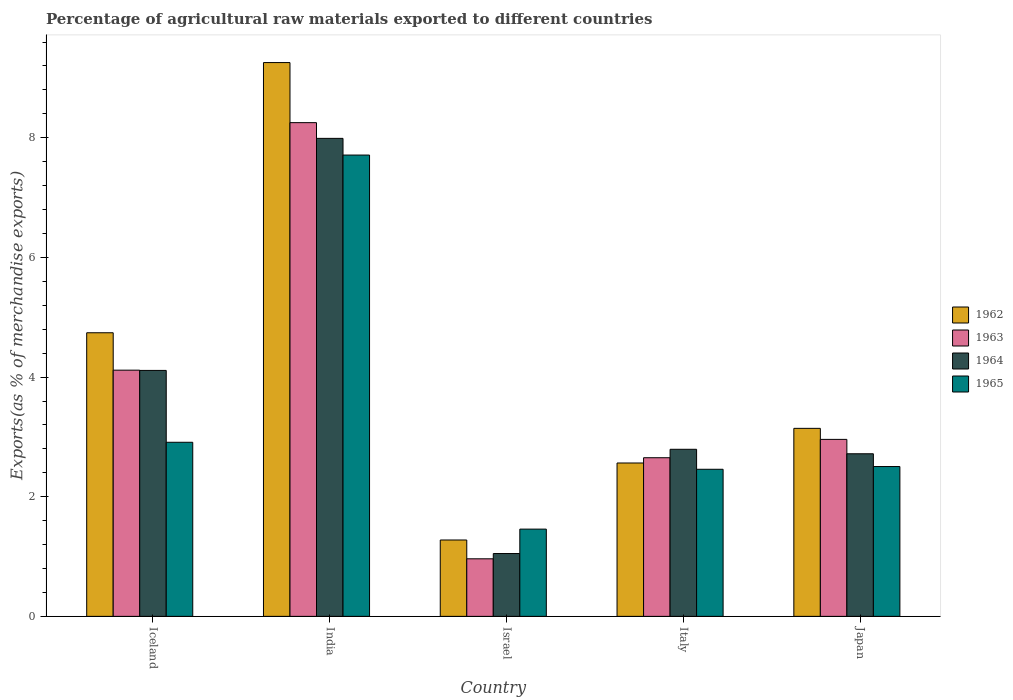How many groups of bars are there?
Offer a very short reply. 5. How many bars are there on the 1st tick from the right?
Keep it short and to the point. 4. What is the percentage of exports to different countries in 1962 in Japan?
Make the answer very short. 3.14. Across all countries, what is the maximum percentage of exports to different countries in 1963?
Offer a terse response. 8.25. Across all countries, what is the minimum percentage of exports to different countries in 1962?
Your answer should be very brief. 1.28. In which country was the percentage of exports to different countries in 1965 minimum?
Offer a terse response. Israel. What is the total percentage of exports to different countries in 1963 in the graph?
Provide a succinct answer. 18.94. What is the difference between the percentage of exports to different countries in 1964 in Israel and that in Japan?
Provide a succinct answer. -1.67. What is the difference between the percentage of exports to different countries in 1965 in India and the percentage of exports to different countries in 1964 in Israel?
Keep it short and to the point. 6.66. What is the average percentage of exports to different countries in 1964 per country?
Provide a succinct answer. 3.73. What is the difference between the percentage of exports to different countries of/in 1962 and percentage of exports to different countries of/in 1964 in Israel?
Keep it short and to the point. 0.23. In how many countries, is the percentage of exports to different countries in 1965 greater than 9.2 %?
Provide a short and direct response. 0. What is the ratio of the percentage of exports to different countries in 1965 in Israel to that in Italy?
Your answer should be very brief. 0.59. Is the percentage of exports to different countries in 1965 in Israel less than that in Italy?
Your answer should be very brief. Yes. What is the difference between the highest and the second highest percentage of exports to different countries in 1962?
Offer a terse response. 6.11. What is the difference between the highest and the lowest percentage of exports to different countries in 1965?
Keep it short and to the point. 6.25. Is the sum of the percentage of exports to different countries in 1965 in Italy and Japan greater than the maximum percentage of exports to different countries in 1962 across all countries?
Your answer should be compact. No. What does the 4th bar from the left in Iceland represents?
Your answer should be compact. 1965. What does the 1st bar from the right in India represents?
Keep it short and to the point. 1965. Are the values on the major ticks of Y-axis written in scientific E-notation?
Provide a short and direct response. No. Does the graph contain any zero values?
Make the answer very short. No. Does the graph contain grids?
Offer a terse response. No. How are the legend labels stacked?
Your answer should be compact. Vertical. What is the title of the graph?
Make the answer very short. Percentage of agricultural raw materials exported to different countries. Does "1989" appear as one of the legend labels in the graph?
Your answer should be very brief. No. What is the label or title of the Y-axis?
Offer a very short reply. Exports(as % of merchandise exports). What is the Exports(as % of merchandise exports) of 1962 in Iceland?
Your answer should be compact. 4.74. What is the Exports(as % of merchandise exports) of 1963 in Iceland?
Your answer should be compact. 4.12. What is the Exports(as % of merchandise exports) of 1964 in Iceland?
Your answer should be very brief. 4.11. What is the Exports(as % of merchandise exports) in 1965 in Iceland?
Your response must be concise. 2.91. What is the Exports(as % of merchandise exports) in 1962 in India?
Make the answer very short. 9.26. What is the Exports(as % of merchandise exports) in 1963 in India?
Give a very brief answer. 8.25. What is the Exports(as % of merchandise exports) in 1964 in India?
Give a very brief answer. 7.99. What is the Exports(as % of merchandise exports) in 1965 in India?
Offer a very short reply. 7.71. What is the Exports(as % of merchandise exports) of 1962 in Israel?
Make the answer very short. 1.28. What is the Exports(as % of merchandise exports) of 1963 in Israel?
Your answer should be compact. 0.96. What is the Exports(as % of merchandise exports) of 1964 in Israel?
Ensure brevity in your answer.  1.05. What is the Exports(as % of merchandise exports) of 1965 in Israel?
Make the answer very short. 1.46. What is the Exports(as % of merchandise exports) of 1962 in Italy?
Your answer should be very brief. 2.56. What is the Exports(as % of merchandise exports) of 1963 in Italy?
Your answer should be compact. 2.65. What is the Exports(as % of merchandise exports) in 1964 in Italy?
Give a very brief answer. 2.79. What is the Exports(as % of merchandise exports) in 1965 in Italy?
Offer a very short reply. 2.46. What is the Exports(as % of merchandise exports) of 1962 in Japan?
Your response must be concise. 3.14. What is the Exports(as % of merchandise exports) of 1963 in Japan?
Offer a terse response. 2.96. What is the Exports(as % of merchandise exports) in 1964 in Japan?
Make the answer very short. 2.72. What is the Exports(as % of merchandise exports) of 1965 in Japan?
Provide a succinct answer. 2.5. Across all countries, what is the maximum Exports(as % of merchandise exports) of 1962?
Keep it short and to the point. 9.26. Across all countries, what is the maximum Exports(as % of merchandise exports) of 1963?
Offer a terse response. 8.25. Across all countries, what is the maximum Exports(as % of merchandise exports) of 1964?
Provide a succinct answer. 7.99. Across all countries, what is the maximum Exports(as % of merchandise exports) of 1965?
Make the answer very short. 7.71. Across all countries, what is the minimum Exports(as % of merchandise exports) in 1962?
Keep it short and to the point. 1.28. Across all countries, what is the minimum Exports(as % of merchandise exports) in 1963?
Offer a terse response. 0.96. Across all countries, what is the minimum Exports(as % of merchandise exports) in 1964?
Keep it short and to the point. 1.05. Across all countries, what is the minimum Exports(as % of merchandise exports) of 1965?
Offer a terse response. 1.46. What is the total Exports(as % of merchandise exports) in 1962 in the graph?
Provide a succinct answer. 20.98. What is the total Exports(as % of merchandise exports) of 1963 in the graph?
Make the answer very short. 18.94. What is the total Exports(as % of merchandise exports) in 1964 in the graph?
Your answer should be compact. 18.66. What is the total Exports(as % of merchandise exports) in 1965 in the graph?
Offer a very short reply. 17.04. What is the difference between the Exports(as % of merchandise exports) in 1962 in Iceland and that in India?
Your response must be concise. -4.52. What is the difference between the Exports(as % of merchandise exports) in 1963 in Iceland and that in India?
Your answer should be very brief. -4.14. What is the difference between the Exports(as % of merchandise exports) of 1964 in Iceland and that in India?
Your answer should be very brief. -3.88. What is the difference between the Exports(as % of merchandise exports) of 1965 in Iceland and that in India?
Keep it short and to the point. -4.8. What is the difference between the Exports(as % of merchandise exports) in 1962 in Iceland and that in Israel?
Provide a short and direct response. 3.46. What is the difference between the Exports(as % of merchandise exports) of 1963 in Iceland and that in Israel?
Provide a short and direct response. 3.15. What is the difference between the Exports(as % of merchandise exports) of 1964 in Iceland and that in Israel?
Provide a succinct answer. 3.06. What is the difference between the Exports(as % of merchandise exports) of 1965 in Iceland and that in Israel?
Your answer should be very brief. 1.45. What is the difference between the Exports(as % of merchandise exports) of 1962 in Iceland and that in Italy?
Your answer should be compact. 2.18. What is the difference between the Exports(as % of merchandise exports) of 1963 in Iceland and that in Italy?
Ensure brevity in your answer.  1.46. What is the difference between the Exports(as % of merchandise exports) in 1964 in Iceland and that in Italy?
Provide a succinct answer. 1.32. What is the difference between the Exports(as % of merchandise exports) of 1965 in Iceland and that in Italy?
Keep it short and to the point. 0.45. What is the difference between the Exports(as % of merchandise exports) of 1962 in Iceland and that in Japan?
Offer a very short reply. 1.6. What is the difference between the Exports(as % of merchandise exports) in 1963 in Iceland and that in Japan?
Give a very brief answer. 1.16. What is the difference between the Exports(as % of merchandise exports) of 1964 in Iceland and that in Japan?
Give a very brief answer. 1.39. What is the difference between the Exports(as % of merchandise exports) in 1965 in Iceland and that in Japan?
Offer a terse response. 0.41. What is the difference between the Exports(as % of merchandise exports) of 1962 in India and that in Israel?
Offer a terse response. 7.98. What is the difference between the Exports(as % of merchandise exports) of 1963 in India and that in Israel?
Your answer should be very brief. 7.29. What is the difference between the Exports(as % of merchandise exports) of 1964 in India and that in Israel?
Offer a very short reply. 6.94. What is the difference between the Exports(as % of merchandise exports) of 1965 in India and that in Israel?
Your answer should be compact. 6.25. What is the difference between the Exports(as % of merchandise exports) of 1962 in India and that in Italy?
Provide a succinct answer. 6.69. What is the difference between the Exports(as % of merchandise exports) of 1963 in India and that in Italy?
Make the answer very short. 5.6. What is the difference between the Exports(as % of merchandise exports) in 1964 in India and that in Italy?
Give a very brief answer. 5.2. What is the difference between the Exports(as % of merchandise exports) in 1965 in India and that in Italy?
Offer a terse response. 5.25. What is the difference between the Exports(as % of merchandise exports) of 1962 in India and that in Japan?
Provide a succinct answer. 6.11. What is the difference between the Exports(as % of merchandise exports) of 1963 in India and that in Japan?
Provide a succinct answer. 5.29. What is the difference between the Exports(as % of merchandise exports) of 1964 in India and that in Japan?
Give a very brief answer. 5.27. What is the difference between the Exports(as % of merchandise exports) of 1965 in India and that in Japan?
Provide a succinct answer. 5.21. What is the difference between the Exports(as % of merchandise exports) of 1962 in Israel and that in Italy?
Your answer should be very brief. -1.29. What is the difference between the Exports(as % of merchandise exports) of 1963 in Israel and that in Italy?
Provide a succinct answer. -1.69. What is the difference between the Exports(as % of merchandise exports) of 1964 in Israel and that in Italy?
Your response must be concise. -1.74. What is the difference between the Exports(as % of merchandise exports) in 1965 in Israel and that in Italy?
Ensure brevity in your answer.  -1. What is the difference between the Exports(as % of merchandise exports) of 1962 in Israel and that in Japan?
Provide a short and direct response. -1.87. What is the difference between the Exports(as % of merchandise exports) of 1963 in Israel and that in Japan?
Make the answer very short. -2. What is the difference between the Exports(as % of merchandise exports) of 1964 in Israel and that in Japan?
Offer a very short reply. -1.67. What is the difference between the Exports(as % of merchandise exports) of 1965 in Israel and that in Japan?
Offer a very short reply. -1.05. What is the difference between the Exports(as % of merchandise exports) in 1962 in Italy and that in Japan?
Your response must be concise. -0.58. What is the difference between the Exports(as % of merchandise exports) in 1963 in Italy and that in Japan?
Your answer should be compact. -0.31. What is the difference between the Exports(as % of merchandise exports) of 1964 in Italy and that in Japan?
Provide a succinct answer. 0.07. What is the difference between the Exports(as % of merchandise exports) of 1965 in Italy and that in Japan?
Give a very brief answer. -0.05. What is the difference between the Exports(as % of merchandise exports) in 1962 in Iceland and the Exports(as % of merchandise exports) in 1963 in India?
Offer a terse response. -3.51. What is the difference between the Exports(as % of merchandise exports) in 1962 in Iceland and the Exports(as % of merchandise exports) in 1964 in India?
Give a very brief answer. -3.25. What is the difference between the Exports(as % of merchandise exports) of 1962 in Iceland and the Exports(as % of merchandise exports) of 1965 in India?
Offer a terse response. -2.97. What is the difference between the Exports(as % of merchandise exports) of 1963 in Iceland and the Exports(as % of merchandise exports) of 1964 in India?
Offer a very short reply. -3.87. What is the difference between the Exports(as % of merchandise exports) of 1963 in Iceland and the Exports(as % of merchandise exports) of 1965 in India?
Your response must be concise. -3.6. What is the difference between the Exports(as % of merchandise exports) in 1964 in Iceland and the Exports(as % of merchandise exports) in 1965 in India?
Offer a very short reply. -3.6. What is the difference between the Exports(as % of merchandise exports) of 1962 in Iceland and the Exports(as % of merchandise exports) of 1963 in Israel?
Keep it short and to the point. 3.78. What is the difference between the Exports(as % of merchandise exports) of 1962 in Iceland and the Exports(as % of merchandise exports) of 1964 in Israel?
Offer a terse response. 3.69. What is the difference between the Exports(as % of merchandise exports) in 1962 in Iceland and the Exports(as % of merchandise exports) in 1965 in Israel?
Give a very brief answer. 3.28. What is the difference between the Exports(as % of merchandise exports) in 1963 in Iceland and the Exports(as % of merchandise exports) in 1964 in Israel?
Your answer should be very brief. 3.07. What is the difference between the Exports(as % of merchandise exports) of 1963 in Iceland and the Exports(as % of merchandise exports) of 1965 in Israel?
Your answer should be compact. 2.66. What is the difference between the Exports(as % of merchandise exports) of 1964 in Iceland and the Exports(as % of merchandise exports) of 1965 in Israel?
Offer a terse response. 2.65. What is the difference between the Exports(as % of merchandise exports) of 1962 in Iceland and the Exports(as % of merchandise exports) of 1963 in Italy?
Your response must be concise. 2.09. What is the difference between the Exports(as % of merchandise exports) in 1962 in Iceland and the Exports(as % of merchandise exports) in 1964 in Italy?
Your answer should be very brief. 1.95. What is the difference between the Exports(as % of merchandise exports) in 1962 in Iceland and the Exports(as % of merchandise exports) in 1965 in Italy?
Provide a short and direct response. 2.28. What is the difference between the Exports(as % of merchandise exports) of 1963 in Iceland and the Exports(as % of merchandise exports) of 1964 in Italy?
Keep it short and to the point. 1.32. What is the difference between the Exports(as % of merchandise exports) of 1963 in Iceland and the Exports(as % of merchandise exports) of 1965 in Italy?
Ensure brevity in your answer.  1.66. What is the difference between the Exports(as % of merchandise exports) in 1964 in Iceland and the Exports(as % of merchandise exports) in 1965 in Italy?
Make the answer very short. 1.65. What is the difference between the Exports(as % of merchandise exports) of 1962 in Iceland and the Exports(as % of merchandise exports) of 1963 in Japan?
Keep it short and to the point. 1.78. What is the difference between the Exports(as % of merchandise exports) in 1962 in Iceland and the Exports(as % of merchandise exports) in 1964 in Japan?
Give a very brief answer. 2.02. What is the difference between the Exports(as % of merchandise exports) of 1962 in Iceland and the Exports(as % of merchandise exports) of 1965 in Japan?
Your response must be concise. 2.24. What is the difference between the Exports(as % of merchandise exports) of 1963 in Iceland and the Exports(as % of merchandise exports) of 1964 in Japan?
Your answer should be compact. 1.4. What is the difference between the Exports(as % of merchandise exports) of 1963 in Iceland and the Exports(as % of merchandise exports) of 1965 in Japan?
Offer a very short reply. 1.61. What is the difference between the Exports(as % of merchandise exports) in 1964 in Iceland and the Exports(as % of merchandise exports) in 1965 in Japan?
Your response must be concise. 1.61. What is the difference between the Exports(as % of merchandise exports) in 1962 in India and the Exports(as % of merchandise exports) in 1963 in Israel?
Your answer should be very brief. 8.3. What is the difference between the Exports(as % of merchandise exports) in 1962 in India and the Exports(as % of merchandise exports) in 1964 in Israel?
Keep it short and to the point. 8.21. What is the difference between the Exports(as % of merchandise exports) in 1962 in India and the Exports(as % of merchandise exports) in 1965 in Israel?
Offer a very short reply. 7.8. What is the difference between the Exports(as % of merchandise exports) of 1963 in India and the Exports(as % of merchandise exports) of 1964 in Israel?
Your response must be concise. 7.2. What is the difference between the Exports(as % of merchandise exports) of 1963 in India and the Exports(as % of merchandise exports) of 1965 in Israel?
Make the answer very short. 6.79. What is the difference between the Exports(as % of merchandise exports) in 1964 in India and the Exports(as % of merchandise exports) in 1965 in Israel?
Your answer should be compact. 6.53. What is the difference between the Exports(as % of merchandise exports) of 1962 in India and the Exports(as % of merchandise exports) of 1963 in Italy?
Give a very brief answer. 6.61. What is the difference between the Exports(as % of merchandise exports) of 1962 in India and the Exports(as % of merchandise exports) of 1964 in Italy?
Provide a succinct answer. 6.46. What is the difference between the Exports(as % of merchandise exports) of 1962 in India and the Exports(as % of merchandise exports) of 1965 in Italy?
Give a very brief answer. 6.8. What is the difference between the Exports(as % of merchandise exports) in 1963 in India and the Exports(as % of merchandise exports) in 1964 in Italy?
Offer a very short reply. 5.46. What is the difference between the Exports(as % of merchandise exports) in 1963 in India and the Exports(as % of merchandise exports) in 1965 in Italy?
Make the answer very short. 5.79. What is the difference between the Exports(as % of merchandise exports) in 1964 in India and the Exports(as % of merchandise exports) in 1965 in Italy?
Make the answer very short. 5.53. What is the difference between the Exports(as % of merchandise exports) of 1962 in India and the Exports(as % of merchandise exports) of 1963 in Japan?
Your answer should be compact. 6.3. What is the difference between the Exports(as % of merchandise exports) of 1962 in India and the Exports(as % of merchandise exports) of 1964 in Japan?
Offer a terse response. 6.54. What is the difference between the Exports(as % of merchandise exports) in 1962 in India and the Exports(as % of merchandise exports) in 1965 in Japan?
Ensure brevity in your answer.  6.75. What is the difference between the Exports(as % of merchandise exports) in 1963 in India and the Exports(as % of merchandise exports) in 1964 in Japan?
Give a very brief answer. 5.54. What is the difference between the Exports(as % of merchandise exports) of 1963 in India and the Exports(as % of merchandise exports) of 1965 in Japan?
Offer a terse response. 5.75. What is the difference between the Exports(as % of merchandise exports) of 1964 in India and the Exports(as % of merchandise exports) of 1965 in Japan?
Give a very brief answer. 5.49. What is the difference between the Exports(as % of merchandise exports) in 1962 in Israel and the Exports(as % of merchandise exports) in 1963 in Italy?
Your answer should be compact. -1.38. What is the difference between the Exports(as % of merchandise exports) of 1962 in Israel and the Exports(as % of merchandise exports) of 1964 in Italy?
Ensure brevity in your answer.  -1.52. What is the difference between the Exports(as % of merchandise exports) of 1962 in Israel and the Exports(as % of merchandise exports) of 1965 in Italy?
Provide a short and direct response. -1.18. What is the difference between the Exports(as % of merchandise exports) in 1963 in Israel and the Exports(as % of merchandise exports) in 1964 in Italy?
Ensure brevity in your answer.  -1.83. What is the difference between the Exports(as % of merchandise exports) of 1963 in Israel and the Exports(as % of merchandise exports) of 1965 in Italy?
Your answer should be compact. -1.5. What is the difference between the Exports(as % of merchandise exports) in 1964 in Israel and the Exports(as % of merchandise exports) in 1965 in Italy?
Ensure brevity in your answer.  -1.41. What is the difference between the Exports(as % of merchandise exports) of 1962 in Israel and the Exports(as % of merchandise exports) of 1963 in Japan?
Ensure brevity in your answer.  -1.68. What is the difference between the Exports(as % of merchandise exports) in 1962 in Israel and the Exports(as % of merchandise exports) in 1964 in Japan?
Keep it short and to the point. -1.44. What is the difference between the Exports(as % of merchandise exports) of 1962 in Israel and the Exports(as % of merchandise exports) of 1965 in Japan?
Your answer should be compact. -1.23. What is the difference between the Exports(as % of merchandise exports) in 1963 in Israel and the Exports(as % of merchandise exports) in 1964 in Japan?
Make the answer very short. -1.76. What is the difference between the Exports(as % of merchandise exports) of 1963 in Israel and the Exports(as % of merchandise exports) of 1965 in Japan?
Make the answer very short. -1.54. What is the difference between the Exports(as % of merchandise exports) of 1964 in Israel and the Exports(as % of merchandise exports) of 1965 in Japan?
Offer a very short reply. -1.45. What is the difference between the Exports(as % of merchandise exports) of 1962 in Italy and the Exports(as % of merchandise exports) of 1963 in Japan?
Ensure brevity in your answer.  -0.39. What is the difference between the Exports(as % of merchandise exports) in 1962 in Italy and the Exports(as % of merchandise exports) in 1964 in Japan?
Keep it short and to the point. -0.15. What is the difference between the Exports(as % of merchandise exports) of 1962 in Italy and the Exports(as % of merchandise exports) of 1965 in Japan?
Your answer should be compact. 0.06. What is the difference between the Exports(as % of merchandise exports) of 1963 in Italy and the Exports(as % of merchandise exports) of 1964 in Japan?
Your answer should be very brief. -0.07. What is the difference between the Exports(as % of merchandise exports) in 1963 in Italy and the Exports(as % of merchandise exports) in 1965 in Japan?
Your response must be concise. 0.15. What is the difference between the Exports(as % of merchandise exports) of 1964 in Italy and the Exports(as % of merchandise exports) of 1965 in Japan?
Your answer should be compact. 0.29. What is the average Exports(as % of merchandise exports) in 1962 per country?
Your answer should be very brief. 4.2. What is the average Exports(as % of merchandise exports) of 1963 per country?
Make the answer very short. 3.79. What is the average Exports(as % of merchandise exports) in 1964 per country?
Provide a short and direct response. 3.73. What is the average Exports(as % of merchandise exports) of 1965 per country?
Your response must be concise. 3.41. What is the difference between the Exports(as % of merchandise exports) of 1962 and Exports(as % of merchandise exports) of 1963 in Iceland?
Make the answer very short. 0.63. What is the difference between the Exports(as % of merchandise exports) in 1962 and Exports(as % of merchandise exports) in 1964 in Iceland?
Give a very brief answer. 0.63. What is the difference between the Exports(as % of merchandise exports) in 1962 and Exports(as % of merchandise exports) in 1965 in Iceland?
Keep it short and to the point. 1.83. What is the difference between the Exports(as % of merchandise exports) of 1963 and Exports(as % of merchandise exports) of 1964 in Iceland?
Your response must be concise. 0. What is the difference between the Exports(as % of merchandise exports) of 1963 and Exports(as % of merchandise exports) of 1965 in Iceland?
Make the answer very short. 1.21. What is the difference between the Exports(as % of merchandise exports) of 1964 and Exports(as % of merchandise exports) of 1965 in Iceland?
Your answer should be compact. 1.2. What is the difference between the Exports(as % of merchandise exports) in 1962 and Exports(as % of merchandise exports) in 1964 in India?
Ensure brevity in your answer.  1.27. What is the difference between the Exports(as % of merchandise exports) in 1962 and Exports(as % of merchandise exports) in 1965 in India?
Keep it short and to the point. 1.55. What is the difference between the Exports(as % of merchandise exports) in 1963 and Exports(as % of merchandise exports) in 1964 in India?
Make the answer very short. 0.26. What is the difference between the Exports(as % of merchandise exports) of 1963 and Exports(as % of merchandise exports) of 1965 in India?
Your answer should be very brief. 0.54. What is the difference between the Exports(as % of merchandise exports) of 1964 and Exports(as % of merchandise exports) of 1965 in India?
Keep it short and to the point. 0.28. What is the difference between the Exports(as % of merchandise exports) in 1962 and Exports(as % of merchandise exports) in 1963 in Israel?
Ensure brevity in your answer.  0.31. What is the difference between the Exports(as % of merchandise exports) of 1962 and Exports(as % of merchandise exports) of 1964 in Israel?
Your response must be concise. 0.23. What is the difference between the Exports(as % of merchandise exports) of 1962 and Exports(as % of merchandise exports) of 1965 in Israel?
Your answer should be very brief. -0.18. What is the difference between the Exports(as % of merchandise exports) of 1963 and Exports(as % of merchandise exports) of 1964 in Israel?
Provide a short and direct response. -0.09. What is the difference between the Exports(as % of merchandise exports) in 1963 and Exports(as % of merchandise exports) in 1965 in Israel?
Give a very brief answer. -0.5. What is the difference between the Exports(as % of merchandise exports) of 1964 and Exports(as % of merchandise exports) of 1965 in Israel?
Give a very brief answer. -0.41. What is the difference between the Exports(as % of merchandise exports) of 1962 and Exports(as % of merchandise exports) of 1963 in Italy?
Offer a very short reply. -0.09. What is the difference between the Exports(as % of merchandise exports) of 1962 and Exports(as % of merchandise exports) of 1964 in Italy?
Your answer should be compact. -0.23. What is the difference between the Exports(as % of merchandise exports) in 1962 and Exports(as % of merchandise exports) in 1965 in Italy?
Provide a succinct answer. 0.1. What is the difference between the Exports(as % of merchandise exports) of 1963 and Exports(as % of merchandise exports) of 1964 in Italy?
Give a very brief answer. -0.14. What is the difference between the Exports(as % of merchandise exports) in 1963 and Exports(as % of merchandise exports) in 1965 in Italy?
Your answer should be very brief. 0.19. What is the difference between the Exports(as % of merchandise exports) of 1964 and Exports(as % of merchandise exports) of 1965 in Italy?
Your answer should be very brief. 0.33. What is the difference between the Exports(as % of merchandise exports) in 1962 and Exports(as % of merchandise exports) in 1963 in Japan?
Keep it short and to the point. 0.18. What is the difference between the Exports(as % of merchandise exports) of 1962 and Exports(as % of merchandise exports) of 1964 in Japan?
Ensure brevity in your answer.  0.42. What is the difference between the Exports(as % of merchandise exports) in 1962 and Exports(as % of merchandise exports) in 1965 in Japan?
Offer a terse response. 0.64. What is the difference between the Exports(as % of merchandise exports) of 1963 and Exports(as % of merchandise exports) of 1964 in Japan?
Provide a succinct answer. 0.24. What is the difference between the Exports(as % of merchandise exports) of 1963 and Exports(as % of merchandise exports) of 1965 in Japan?
Provide a short and direct response. 0.45. What is the difference between the Exports(as % of merchandise exports) in 1964 and Exports(as % of merchandise exports) in 1965 in Japan?
Your response must be concise. 0.21. What is the ratio of the Exports(as % of merchandise exports) of 1962 in Iceland to that in India?
Your answer should be very brief. 0.51. What is the ratio of the Exports(as % of merchandise exports) of 1963 in Iceland to that in India?
Your response must be concise. 0.5. What is the ratio of the Exports(as % of merchandise exports) in 1964 in Iceland to that in India?
Offer a terse response. 0.51. What is the ratio of the Exports(as % of merchandise exports) of 1965 in Iceland to that in India?
Your answer should be compact. 0.38. What is the ratio of the Exports(as % of merchandise exports) of 1962 in Iceland to that in Israel?
Your response must be concise. 3.71. What is the ratio of the Exports(as % of merchandise exports) of 1963 in Iceland to that in Israel?
Your answer should be compact. 4.28. What is the ratio of the Exports(as % of merchandise exports) of 1964 in Iceland to that in Israel?
Provide a succinct answer. 3.92. What is the ratio of the Exports(as % of merchandise exports) of 1965 in Iceland to that in Israel?
Your answer should be very brief. 2. What is the ratio of the Exports(as % of merchandise exports) in 1962 in Iceland to that in Italy?
Offer a terse response. 1.85. What is the ratio of the Exports(as % of merchandise exports) of 1963 in Iceland to that in Italy?
Your response must be concise. 1.55. What is the ratio of the Exports(as % of merchandise exports) in 1964 in Iceland to that in Italy?
Provide a short and direct response. 1.47. What is the ratio of the Exports(as % of merchandise exports) in 1965 in Iceland to that in Italy?
Provide a succinct answer. 1.18. What is the ratio of the Exports(as % of merchandise exports) in 1962 in Iceland to that in Japan?
Keep it short and to the point. 1.51. What is the ratio of the Exports(as % of merchandise exports) of 1963 in Iceland to that in Japan?
Provide a succinct answer. 1.39. What is the ratio of the Exports(as % of merchandise exports) of 1964 in Iceland to that in Japan?
Keep it short and to the point. 1.51. What is the ratio of the Exports(as % of merchandise exports) of 1965 in Iceland to that in Japan?
Your answer should be compact. 1.16. What is the ratio of the Exports(as % of merchandise exports) of 1962 in India to that in Israel?
Ensure brevity in your answer.  7.25. What is the ratio of the Exports(as % of merchandise exports) in 1963 in India to that in Israel?
Offer a terse response. 8.58. What is the ratio of the Exports(as % of merchandise exports) in 1964 in India to that in Israel?
Give a very brief answer. 7.61. What is the ratio of the Exports(as % of merchandise exports) in 1965 in India to that in Israel?
Ensure brevity in your answer.  5.29. What is the ratio of the Exports(as % of merchandise exports) in 1962 in India to that in Italy?
Ensure brevity in your answer.  3.61. What is the ratio of the Exports(as % of merchandise exports) of 1963 in India to that in Italy?
Keep it short and to the point. 3.11. What is the ratio of the Exports(as % of merchandise exports) in 1964 in India to that in Italy?
Give a very brief answer. 2.86. What is the ratio of the Exports(as % of merchandise exports) in 1965 in India to that in Italy?
Your answer should be very brief. 3.14. What is the ratio of the Exports(as % of merchandise exports) in 1962 in India to that in Japan?
Make the answer very short. 2.95. What is the ratio of the Exports(as % of merchandise exports) of 1963 in India to that in Japan?
Provide a succinct answer. 2.79. What is the ratio of the Exports(as % of merchandise exports) of 1964 in India to that in Japan?
Provide a succinct answer. 2.94. What is the ratio of the Exports(as % of merchandise exports) of 1965 in India to that in Japan?
Provide a short and direct response. 3.08. What is the ratio of the Exports(as % of merchandise exports) in 1962 in Israel to that in Italy?
Provide a short and direct response. 0.5. What is the ratio of the Exports(as % of merchandise exports) of 1963 in Israel to that in Italy?
Give a very brief answer. 0.36. What is the ratio of the Exports(as % of merchandise exports) of 1964 in Israel to that in Italy?
Make the answer very short. 0.38. What is the ratio of the Exports(as % of merchandise exports) in 1965 in Israel to that in Italy?
Provide a short and direct response. 0.59. What is the ratio of the Exports(as % of merchandise exports) of 1962 in Israel to that in Japan?
Keep it short and to the point. 0.41. What is the ratio of the Exports(as % of merchandise exports) in 1963 in Israel to that in Japan?
Offer a terse response. 0.33. What is the ratio of the Exports(as % of merchandise exports) of 1964 in Israel to that in Japan?
Keep it short and to the point. 0.39. What is the ratio of the Exports(as % of merchandise exports) of 1965 in Israel to that in Japan?
Your answer should be very brief. 0.58. What is the ratio of the Exports(as % of merchandise exports) of 1962 in Italy to that in Japan?
Make the answer very short. 0.82. What is the ratio of the Exports(as % of merchandise exports) in 1963 in Italy to that in Japan?
Offer a very short reply. 0.9. What is the ratio of the Exports(as % of merchandise exports) of 1964 in Italy to that in Japan?
Offer a terse response. 1.03. What is the ratio of the Exports(as % of merchandise exports) in 1965 in Italy to that in Japan?
Keep it short and to the point. 0.98. What is the difference between the highest and the second highest Exports(as % of merchandise exports) in 1962?
Keep it short and to the point. 4.52. What is the difference between the highest and the second highest Exports(as % of merchandise exports) of 1963?
Your answer should be compact. 4.14. What is the difference between the highest and the second highest Exports(as % of merchandise exports) in 1964?
Offer a terse response. 3.88. What is the difference between the highest and the second highest Exports(as % of merchandise exports) in 1965?
Provide a succinct answer. 4.8. What is the difference between the highest and the lowest Exports(as % of merchandise exports) of 1962?
Your response must be concise. 7.98. What is the difference between the highest and the lowest Exports(as % of merchandise exports) in 1963?
Provide a short and direct response. 7.29. What is the difference between the highest and the lowest Exports(as % of merchandise exports) of 1964?
Your answer should be compact. 6.94. What is the difference between the highest and the lowest Exports(as % of merchandise exports) in 1965?
Your response must be concise. 6.25. 